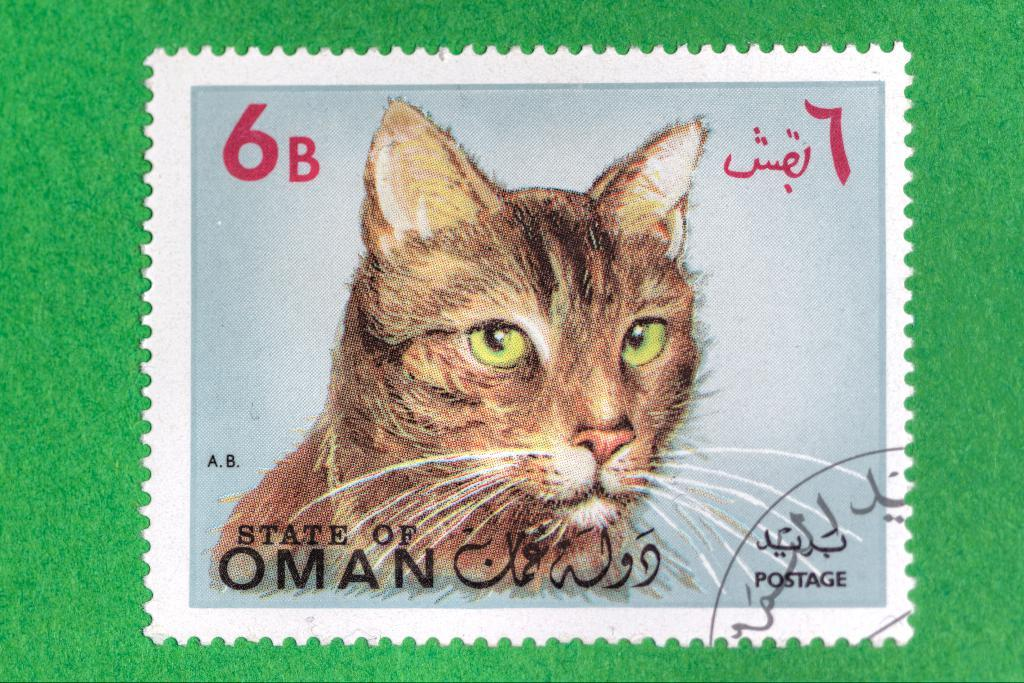What is the main subject of the image? The main subject of the image is a postage stamp. What is the color of the surface the stamp is on? The postage stamp is on a green surface. What is depicted on the stamp? There is a cat depicted on the stamp. Are there any words or letters on the stamp? Yes, there is writing on the stamp. What type of flesh can be seen on the turkey depicted on the stamp? There is no turkey depicted on the stamp; it features a cat. Can you tell me how many wrens are shown on the stamp? There are no wrens depicted on the stamp; it features a cat. 